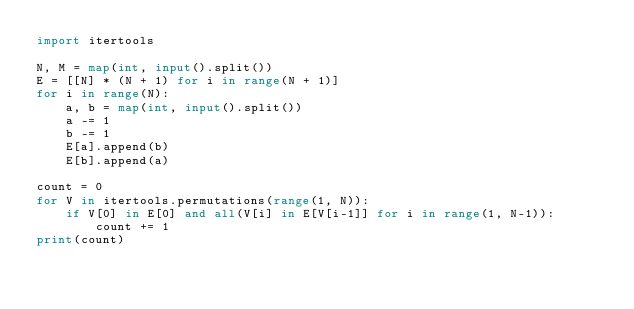Convert code to text. <code><loc_0><loc_0><loc_500><loc_500><_Python_>import itertools

N, M = map(int, input().split())
E = [[N] * (N + 1) for i in range(N + 1)]
for i in range(N):
    a, b = map(int, input().split())
    a -= 1
    b -= 1
    E[a].append(b)
    E[b].append(a)

count = 0
for V in itertools.permutations(range(1, N)):
    if V[0] in E[0] and all(V[i] in E[V[i-1]] for i in range(1, N-1)):
        count += 1
print(count)        
</code> 